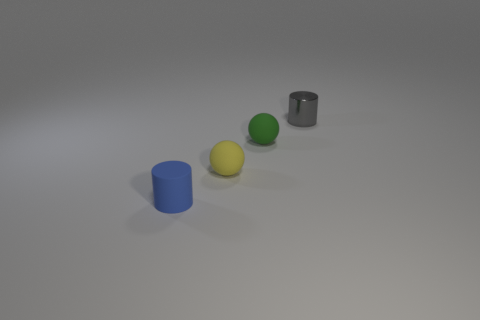Add 4 large blue things. How many objects exist? 8 Subtract all big cyan blocks. Subtract all green spheres. How many objects are left? 3 Add 1 tiny spheres. How many tiny spheres are left? 3 Add 4 brown metal cylinders. How many brown metal cylinders exist? 4 Subtract 0 yellow cubes. How many objects are left? 4 